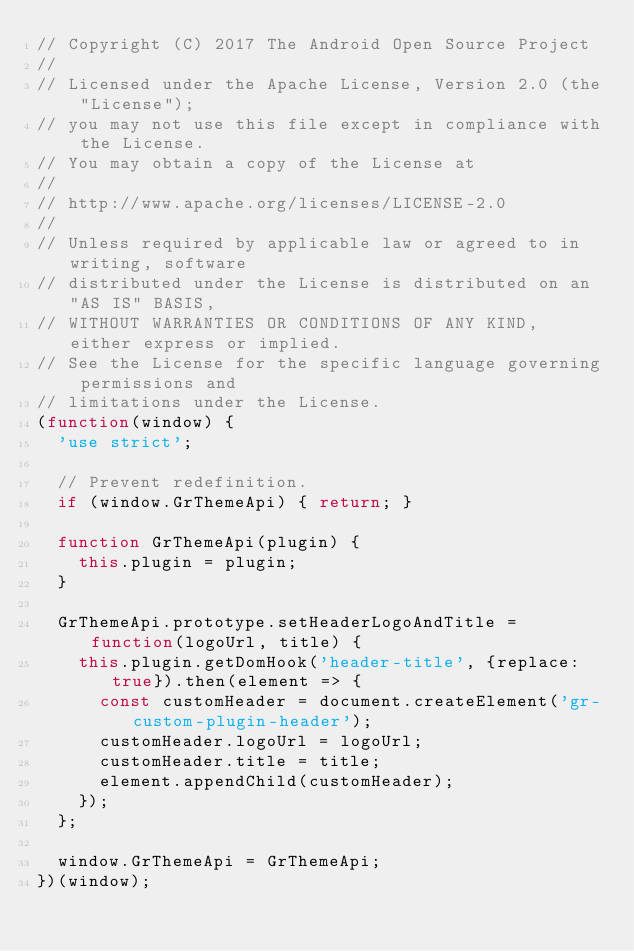Convert code to text. <code><loc_0><loc_0><loc_500><loc_500><_JavaScript_>// Copyright (C) 2017 The Android Open Source Project
//
// Licensed under the Apache License, Version 2.0 (the "License");
// you may not use this file except in compliance with the License.
// You may obtain a copy of the License at
//
// http://www.apache.org/licenses/LICENSE-2.0
//
// Unless required by applicable law or agreed to in writing, software
// distributed under the License is distributed on an "AS IS" BASIS,
// WITHOUT WARRANTIES OR CONDITIONS OF ANY KIND, either express or implied.
// See the License for the specific language governing permissions and
// limitations under the License.
(function(window) {
  'use strict';

  // Prevent redefinition.
  if (window.GrThemeApi) { return; }

  function GrThemeApi(plugin) {
    this.plugin = plugin;
  }

  GrThemeApi.prototype.setHeaderLogoAndTitle = function(logoUrl, title) {
    this.plugin.getDomHook('header-title', {replace: true}).then(element => {
      const customHeader = document.createElement('gr-custom-plugin-header');
      customHeader.logoUrl = logoUrl;
      customHeader.title = title;
      element.appendChild(customHeader);
    });
  };

  window.GrThemeApi = GrThemeApi;
})(window);
</code> 